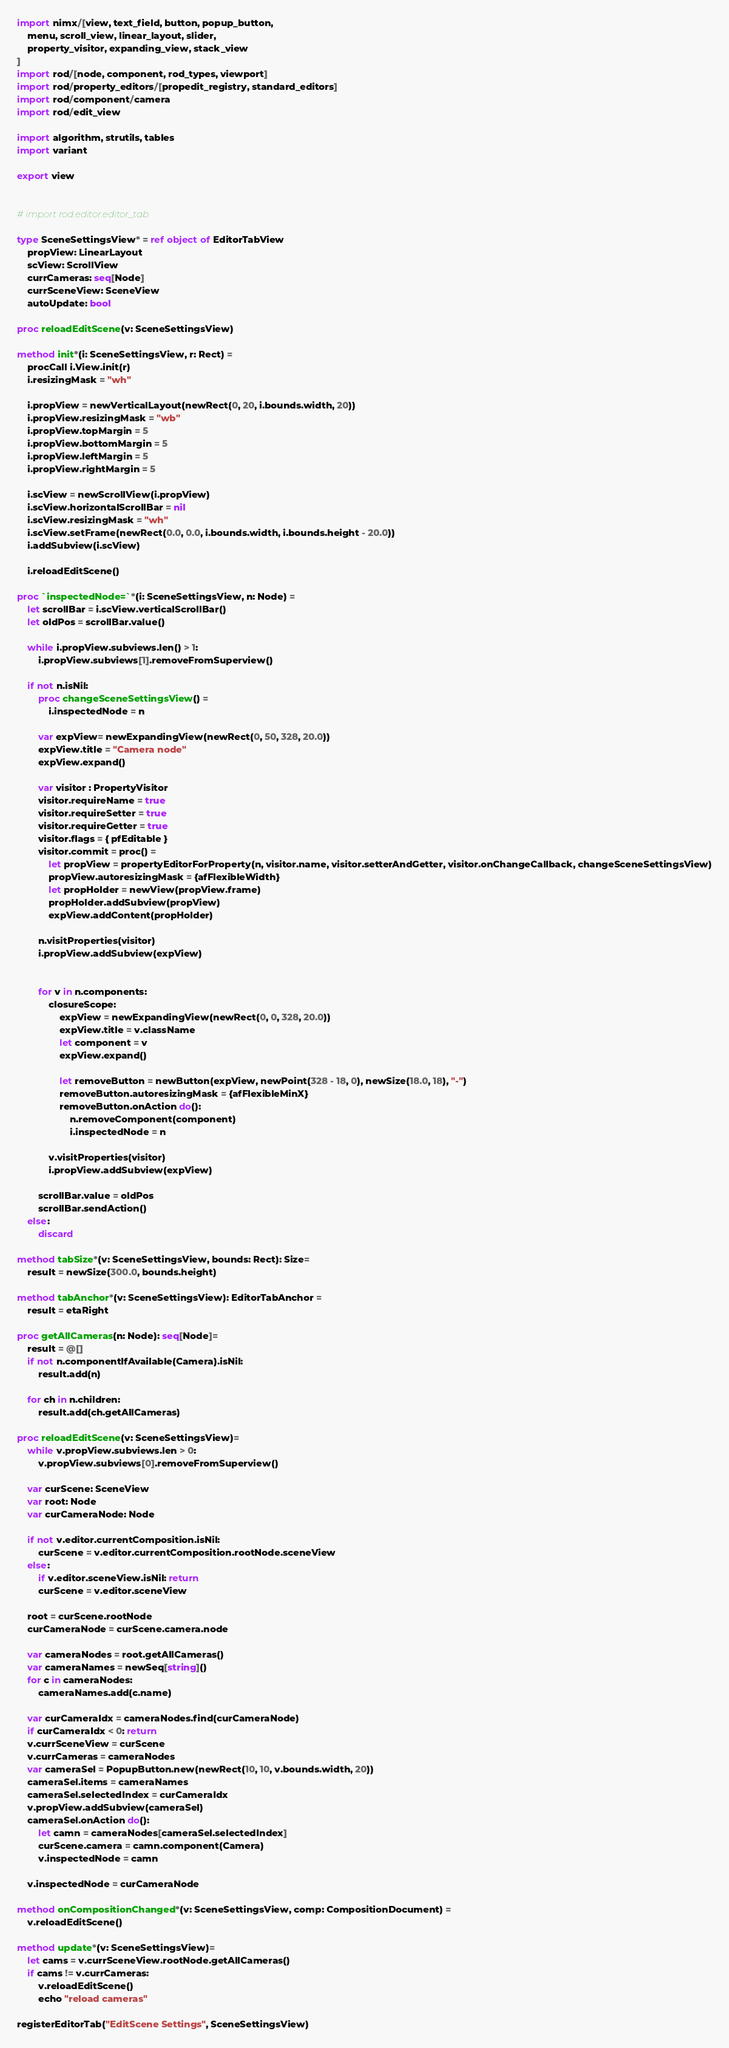Convert code to text. <code><loc_0><loc_0><loc_500><loc_500><_Nim_>import nimx/[view, text_field, button, popup_button,
    menu, scroll_view, linear_layout, slider,
    property_visitor, expanding_view, stack_view
]
import rod/[node, component, rod_types, viewport]
import rod/property_editors/[propedit_registry, standard_editors]
import rod/component/camera
import rod/edit_view

import algorithm, strutils, tables
import variant

export view


# import rod.editor.editor_tab

type SceneSettingsView* = ref object of EditorTabView
    propView: LinearLayout
    scView: ScrollView
    currCameras: seq[Node]
    currSceneView: SceneView
    autoUpdate: bool

proc reloadEditScene(v: SceneSettingsView)

method init*(i: SceneSettingsView, r: Rect) =
    procCall i.View.init(r)
    i.resizingMask = "wh"

    i.propView = newVerticalLayout(newRect(0, 20, i.bounds.width, 20))
    i.propView.resizingMask = "wb"
    i.propView.topMargin = 5
    i.propView.bottomMargin = 5
    i.propView.leftMargin = 5
    i.propView.rightMargin = 5

    i.scView = newScrollView(i.propView)
    i.scView.horizontalScrollBar = nil
    i.scView.resizingMask = "wh"
    i.scView.setFrame(newRect(0.0, 0.0, i.bounds.width, i.bounds.height - 20.0))
    i.addSubview(i.scView)

    i.reloadEditScene()

proc `inspectedNode=`*(i: SceneSettingsView, n: Node) =
    let scrollBar = i.scView.verticalScrollBar()
    let oldPos = scrollBar.value()

    while i.propView.subviews.len() > 1:
        i.propView.subviews[1].removeFromSuperview()

    if not n.isNil:
        proc changeSceneSettingsView() =
            i.inspectedNode = n

        var expView= newExpandingView(newRect(0, 50, 328, 20.0))
        expView.title = "Camera node"
        expView.expand()

        var visitor : PropertyVisitor
        visitor.requireName = true
        visitor.requireSetter = true
        visitor.requireGetter = true
        visitor.flags = { pfEditable }
        visitor.commit = proc() =
            let propView = propertyEditorForProperty(n, visitor.name, visitor.setterAndGetter, visitor.onChangeCallback, changeSceneSettingsView)
            propView.autoresizingMask = {afFlexibleWidth}
            let propHolder = newView(propView.frame)
            propHolder.addSubview(propView)
            expView.addContent(propHolder)

        n.visitProperties(visitor)
        i.propView.addSubview(expView)


        for v in n.components:
            closureScope:
                expView = newExpandingView(newRect(0, 0, 328, 20.0))
                expView.title = v.className
                let component = v
                expView.expand()

                let removeButton = newButton(expView, newPoint(328 - 18, 0), newSize(18.0, 18), "-")
                removeButton.autoresizingMask = {afFlexibleMinX}
                removeButton.onAction do():
                    n.removeComponent(component)
                    i.inspectedNode = n

            v.visitProperties(visitor)
            i.propView.addSubview(expView)

        scrollBar.value = oldPos
        scrollBar.sendAction()
    else:
        discard

method tabSize*(v: SceneSettingsView, bounds: Rect): Size=
    result = newSize(300.0, bounds.height)

method tabAnchor*(v: SceneSettingsView): EditorTabAnchor =
    result = etaRight

proc getAllCameras(n: Node): seq[Node]=
    result = @[]
    if not n.componentIfAvailable(Camera).isNil:
        result.add(n)

    for ch in n.children:
        result.add(ch.getAllCameras)

proc reloadEditScene(v: SceneSettingsView)=
    while v.propView.subviews.len > 0:
        v.propView.subviews[0].removeFromSuperview()

    var curScene: SceneView
    var root: Node
    var curCameraNode: Node

    if not v.editor.currentComposition.isNil:
        curScene = v.editor.currentComposition.rootNode.sceneView
    else:
        if v.editor.sceneView.isNil: return
        curScene = v.editor.sceneView

    root = curScene.rootNode
    curCameraNode = curScene.camera.node

    var cameraNodes = root.getAllCameras()
    var cameraNames = newSeq[string]()
    for c in cameraNodes:
        cameraNames.add(c.name)

    var curCameraIdx = cameraNodes.find(curCameraNode)
    if curCameraIdx < 0: return
    v.currSceneView = curScene
    v.currCameras = cameraNodes
    var cameraSel = PopupButton.new(newRect(10, 10, v.bounds.width, 20))
    cameraSel.items = cameraNames
    cameraSel.selectedIndex = curCameraIdx
    v.propView.addSubview(cameraSel)
    cameraSel.onAction do():
        let camn = cameraNodes[cameraSel.selectedIndex]
        curScene.camera = camn.component(Camera)
        v.inspectedNode = camn

    v.inspectedNode = curCameraNode

method onCompositionChanged*(v: SceneSettingsView, comp: CompositionDocument) =
    v.reloadEditScene()

method update*(v: SceneSettingsView)=
    let cams = v.currSceneView.rootNode.getAllCameras()
    if cams != v.currCameras:
        v.reloadEditScene()
        echo "reload cameras"

registerEditorTab("EditScene Settings", SceneSettingsView)
</code> 